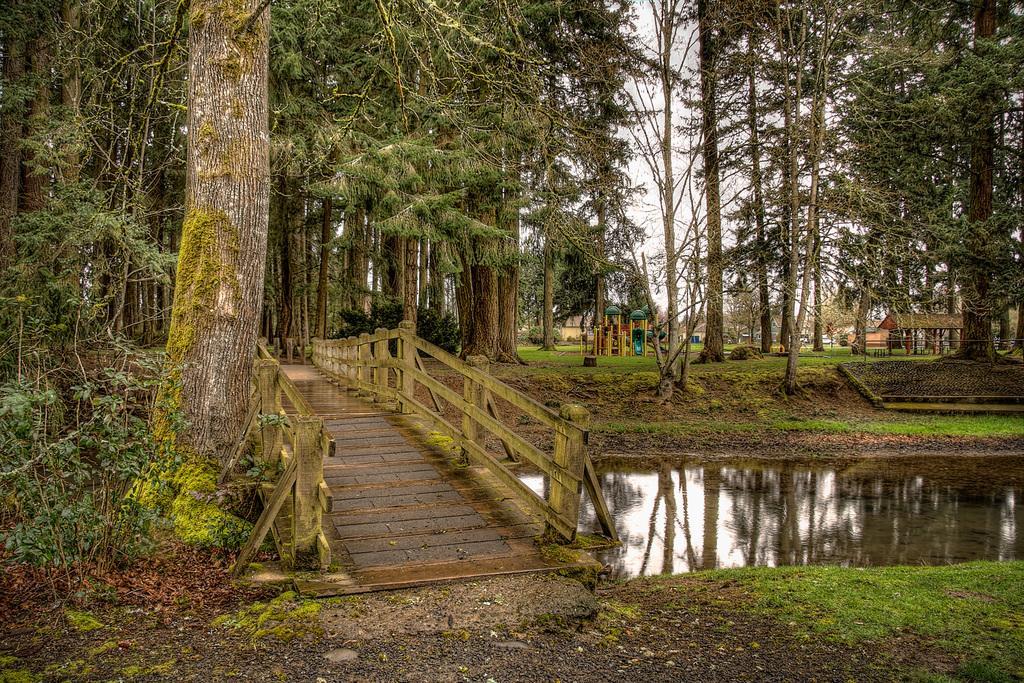In one or two sentences, can you explain what this image depicts? Here in this picture in the middle we can see a wooden bridge with railing present on the ground and in the middle of it we can see water present and we can see the ground is covered with grass and we can also see plants and trees present and we can see the sky is cloudy. 